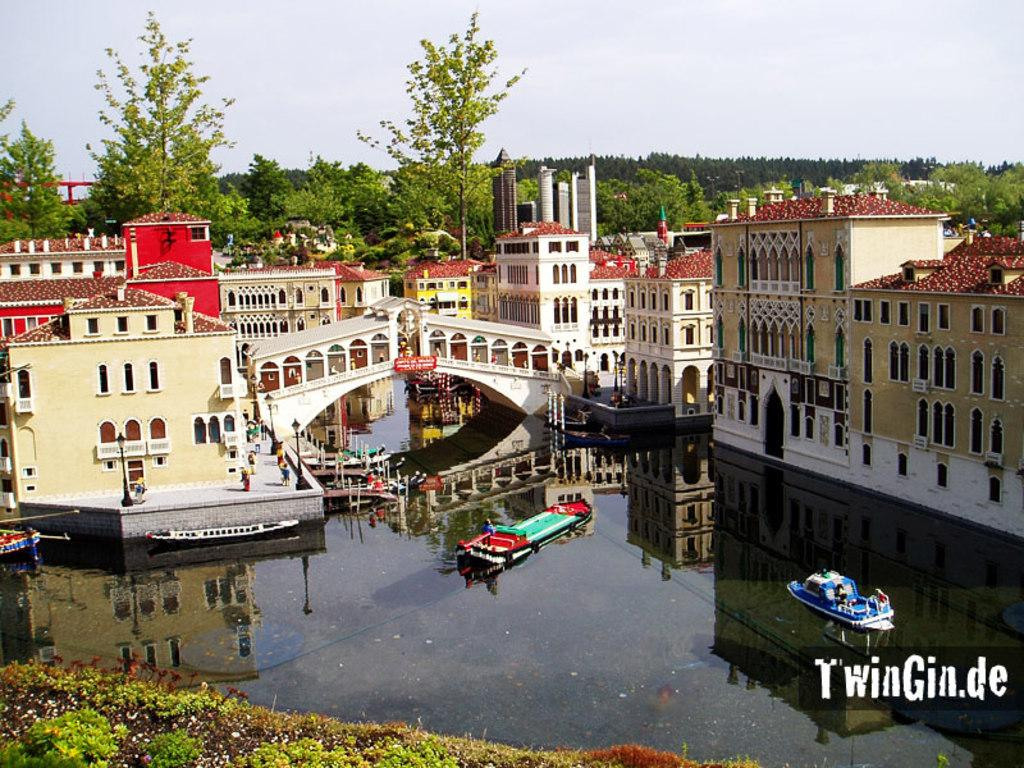What is on the water in the image? There are boats on the water in the image. What structures can be seen in the image? There are buildings and a bridge visible in the image. What are the people in the image doing? There are people on the road in the image. What type of vertical structures are present in the image? Light poles are present in the image. What type of vegetation is visible in the image? Trees are visible in the image. What is visible in the background of the image? The sky is visible in the background of the image. What type of instrument is being played by the person on the bridge in the image? There is no person playing an instrument on the bridge in the image. What type of lamp is hanging from the tree in the image? There are no lamps hanging from trees in the image. 